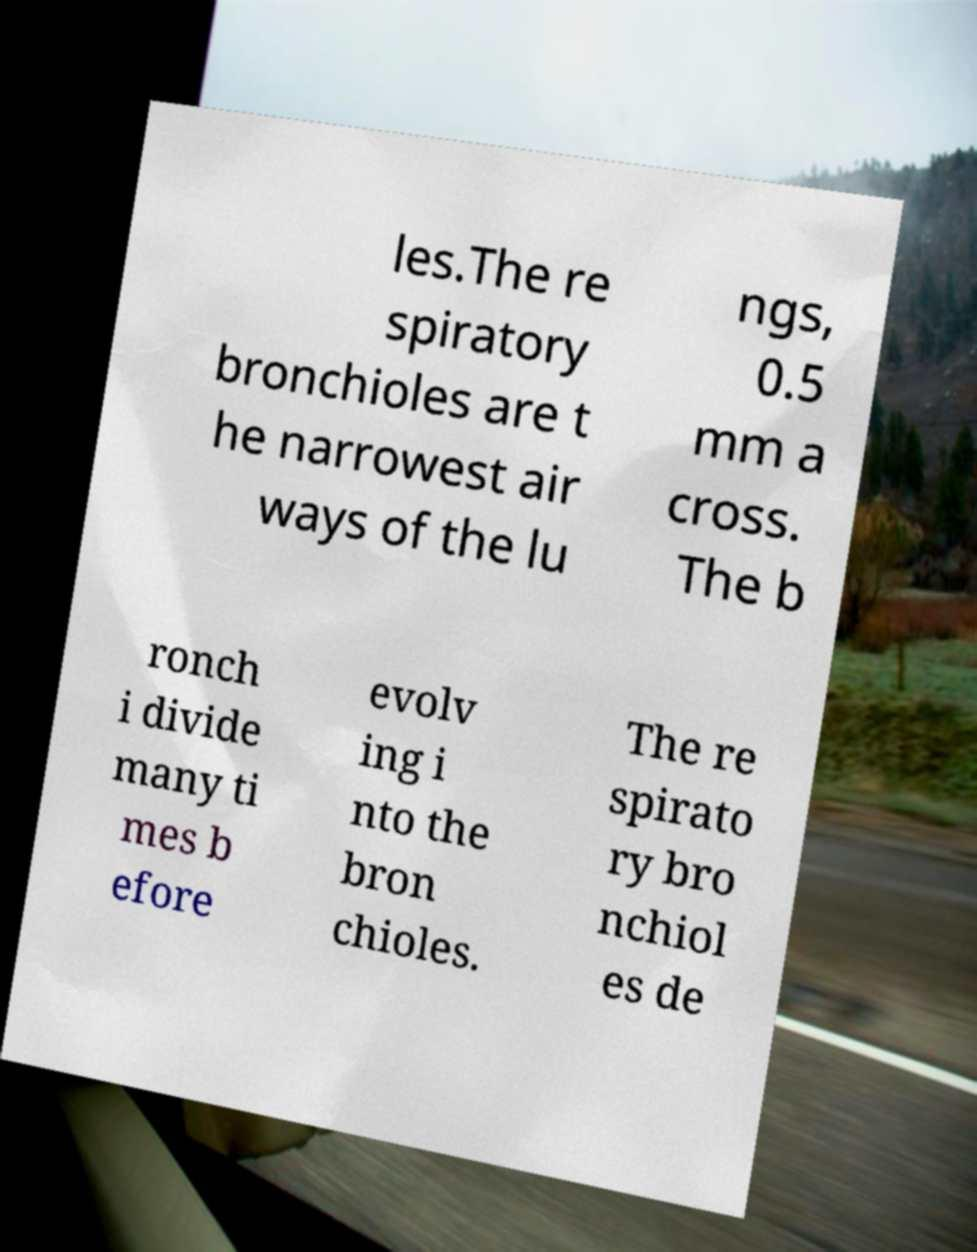What messages or text are displayed in this image? I need them in a readable, typed format. les.The re spiratory bronchioles are t he narrowest air ways of the lu ngs, 0.5 mm a cross. The b ronch i divide many ti mes b efore evolv ing i nto the bron chioles. The re spirato ry bro nchiol es de 